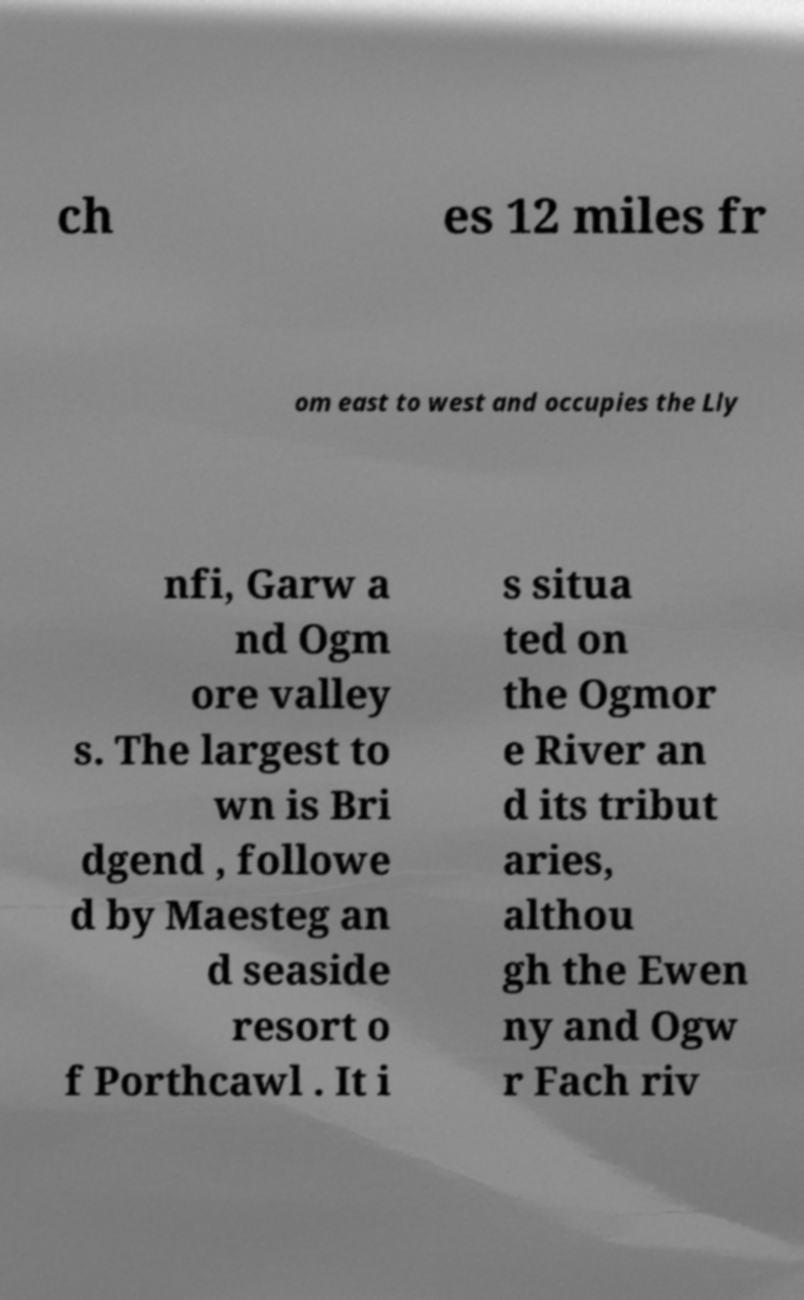Please read and relay the text visible in this image. What does it say? ch es 12 miles fr om east to west and occupies the Lly nfi, Garw a nd Ogm ore valley s. The largest to wn is Bri dgend , followe d by Maesteg an d seaside resort o f Porthcawl . It i s situa ted on the Ogmor e River an d its tribut aries, althou gh the Ewen ny and Ogw r Fach riv 